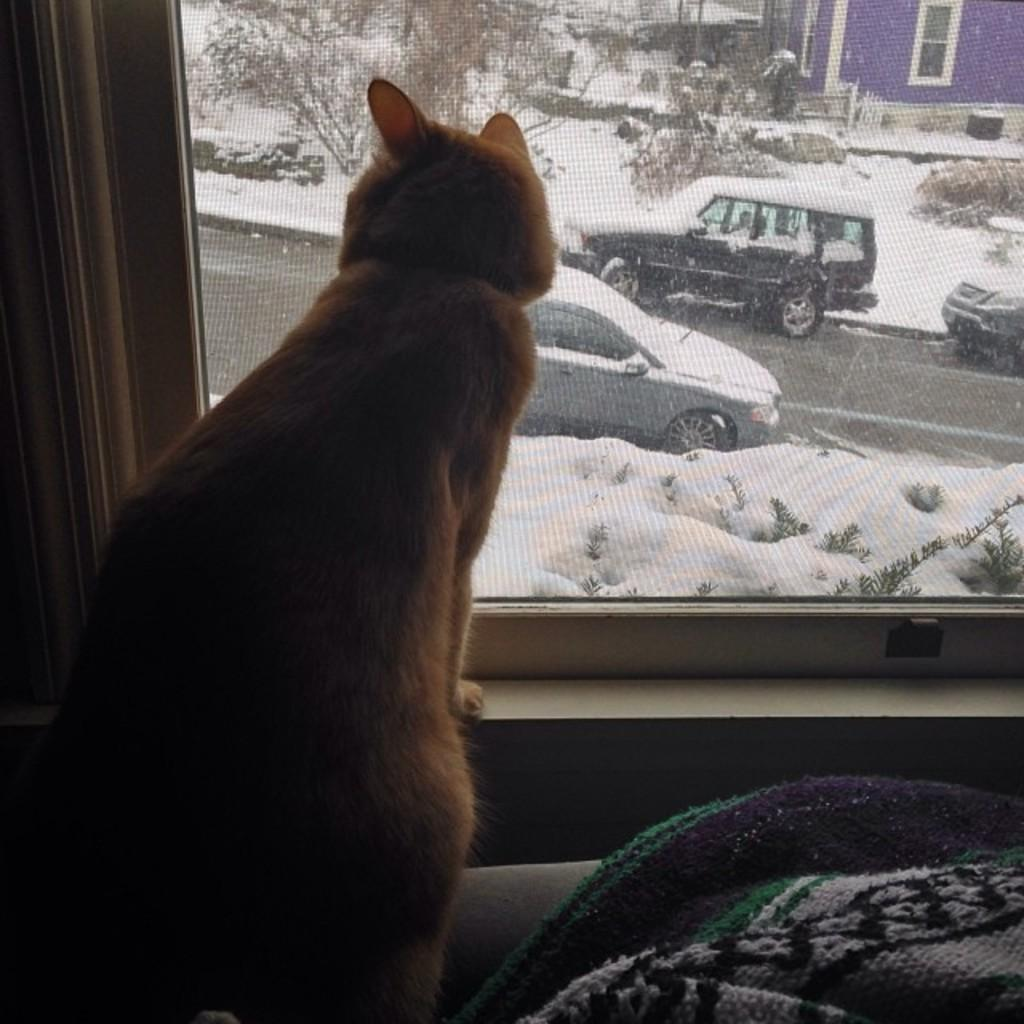What type of animal is in the image? There is a cat in the image. Where is the cat located in relation to other objects? The cat is standing near a window. What can be seen through the window? Cars, snow, and trees are visible behind the window. What type of van is parked in front of the window in the image? There is no van present in the image; only cars, snow, and trees are visible behind the window. 